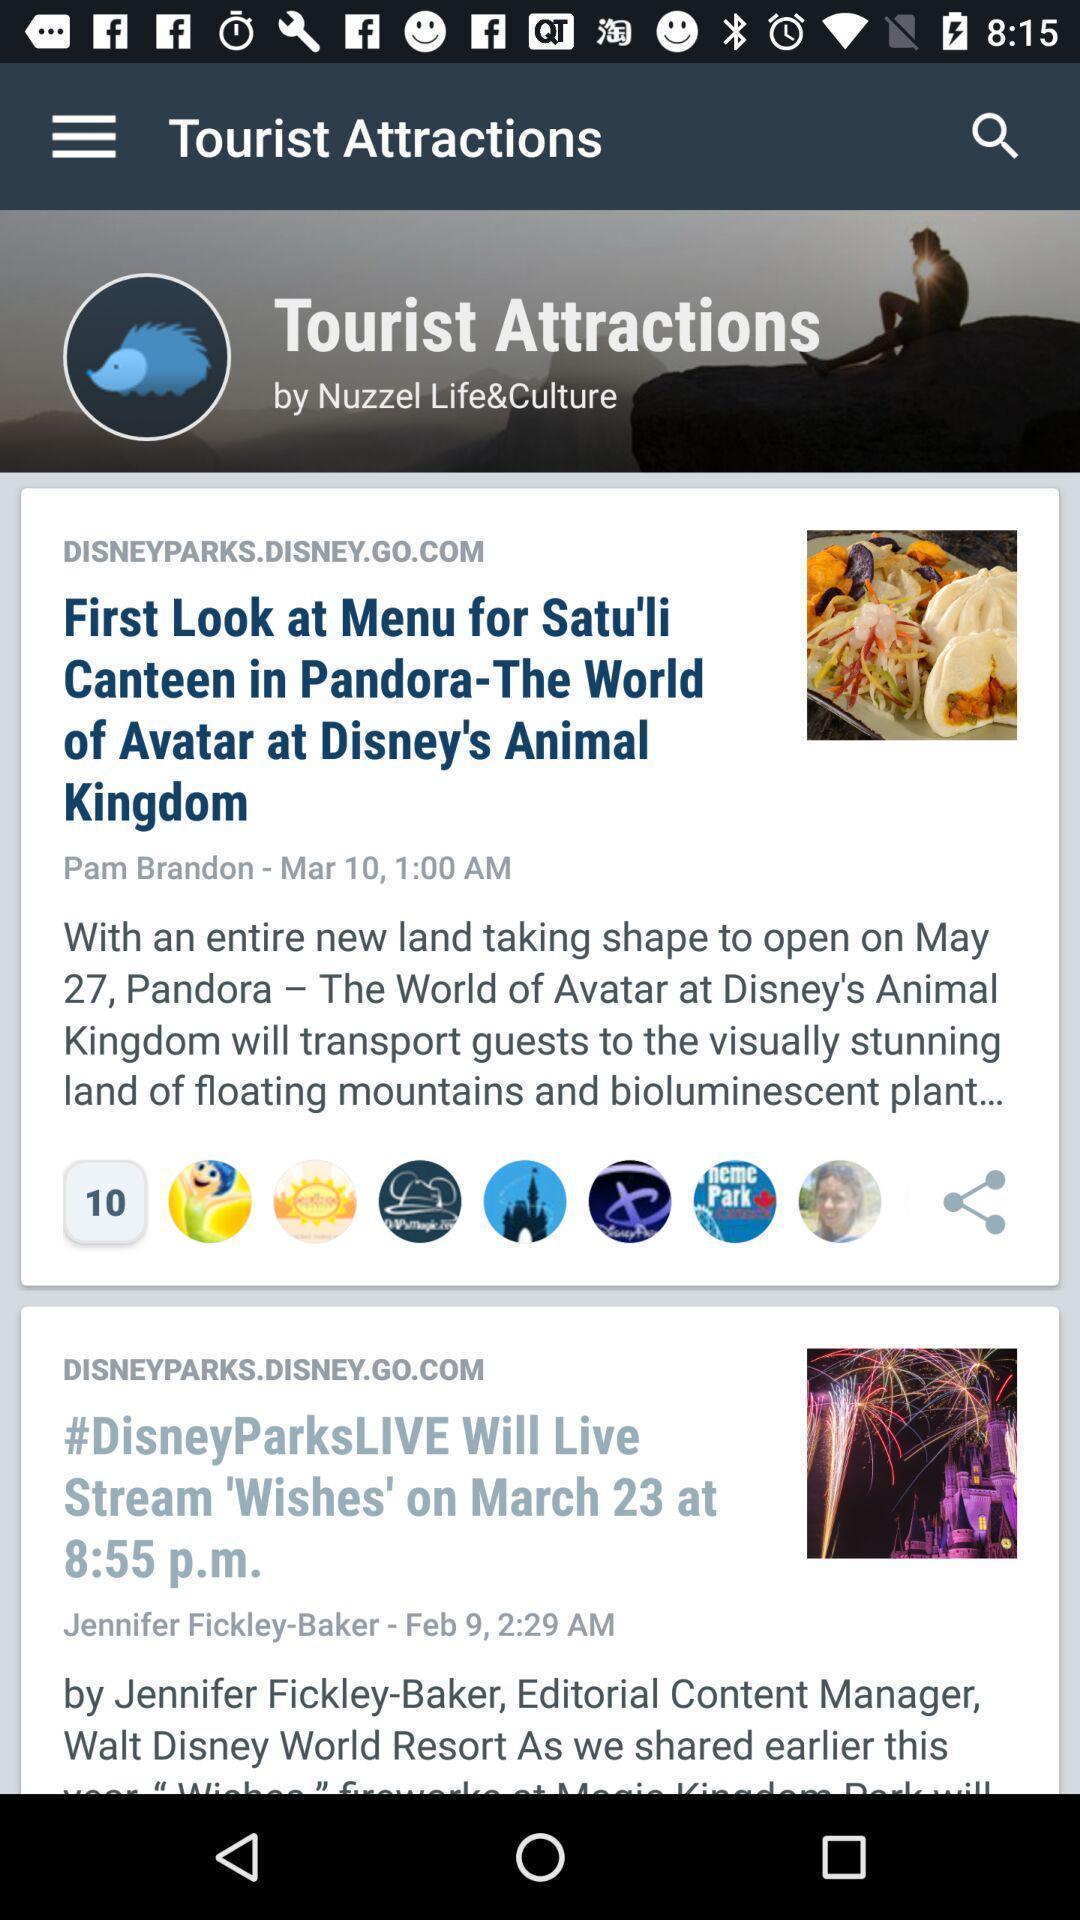Summarize the information in this screenshot. Page displaying various articles in travel application. 